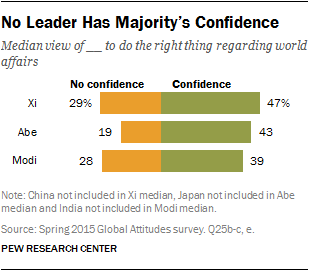List a handful of essential elements in this visual. The leader who received the greatest difference between their confidence and lack of confidence is Abe. The color yellow is represented by the value of no confidence. 